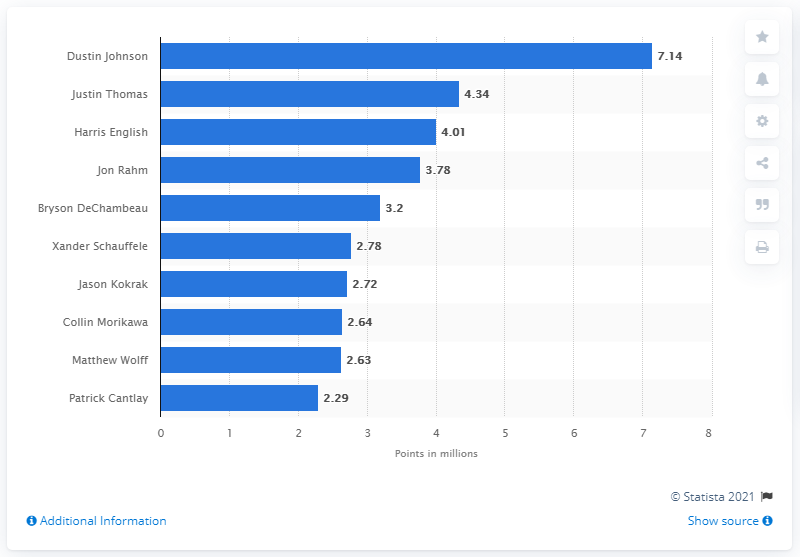List a handful of essential elements in this visual. As of my knowledge cutoff date of September 2021, Dustin Johnson is the top professional golfer with the most PGA Championship points. Dustin Johnson had 7.14 points in the PGA Championship. 